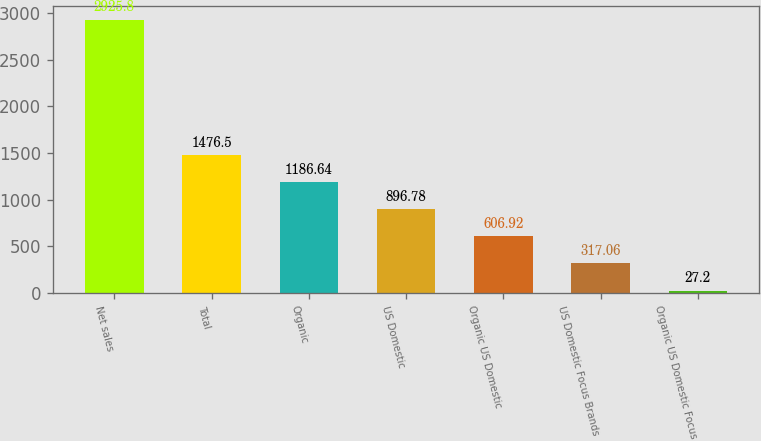Convert chart to OTSL. <chart><loc_0><loc_0><loc_500><loc_500><bar_chart><fcel>Net sales<fcel>Total<fcel>Organic<fcel>US Domestic<fcel>Organic US Domestic<fcel>US Domestic Focus Brands<fcel>Organic US Domestic Focus<nl><fcel>2925.8<fcel>1476.5<fcel>1186.64<fcel>896.78<fcel>606.92<fcel>317.06<fcel>27.2<nl></chart> 